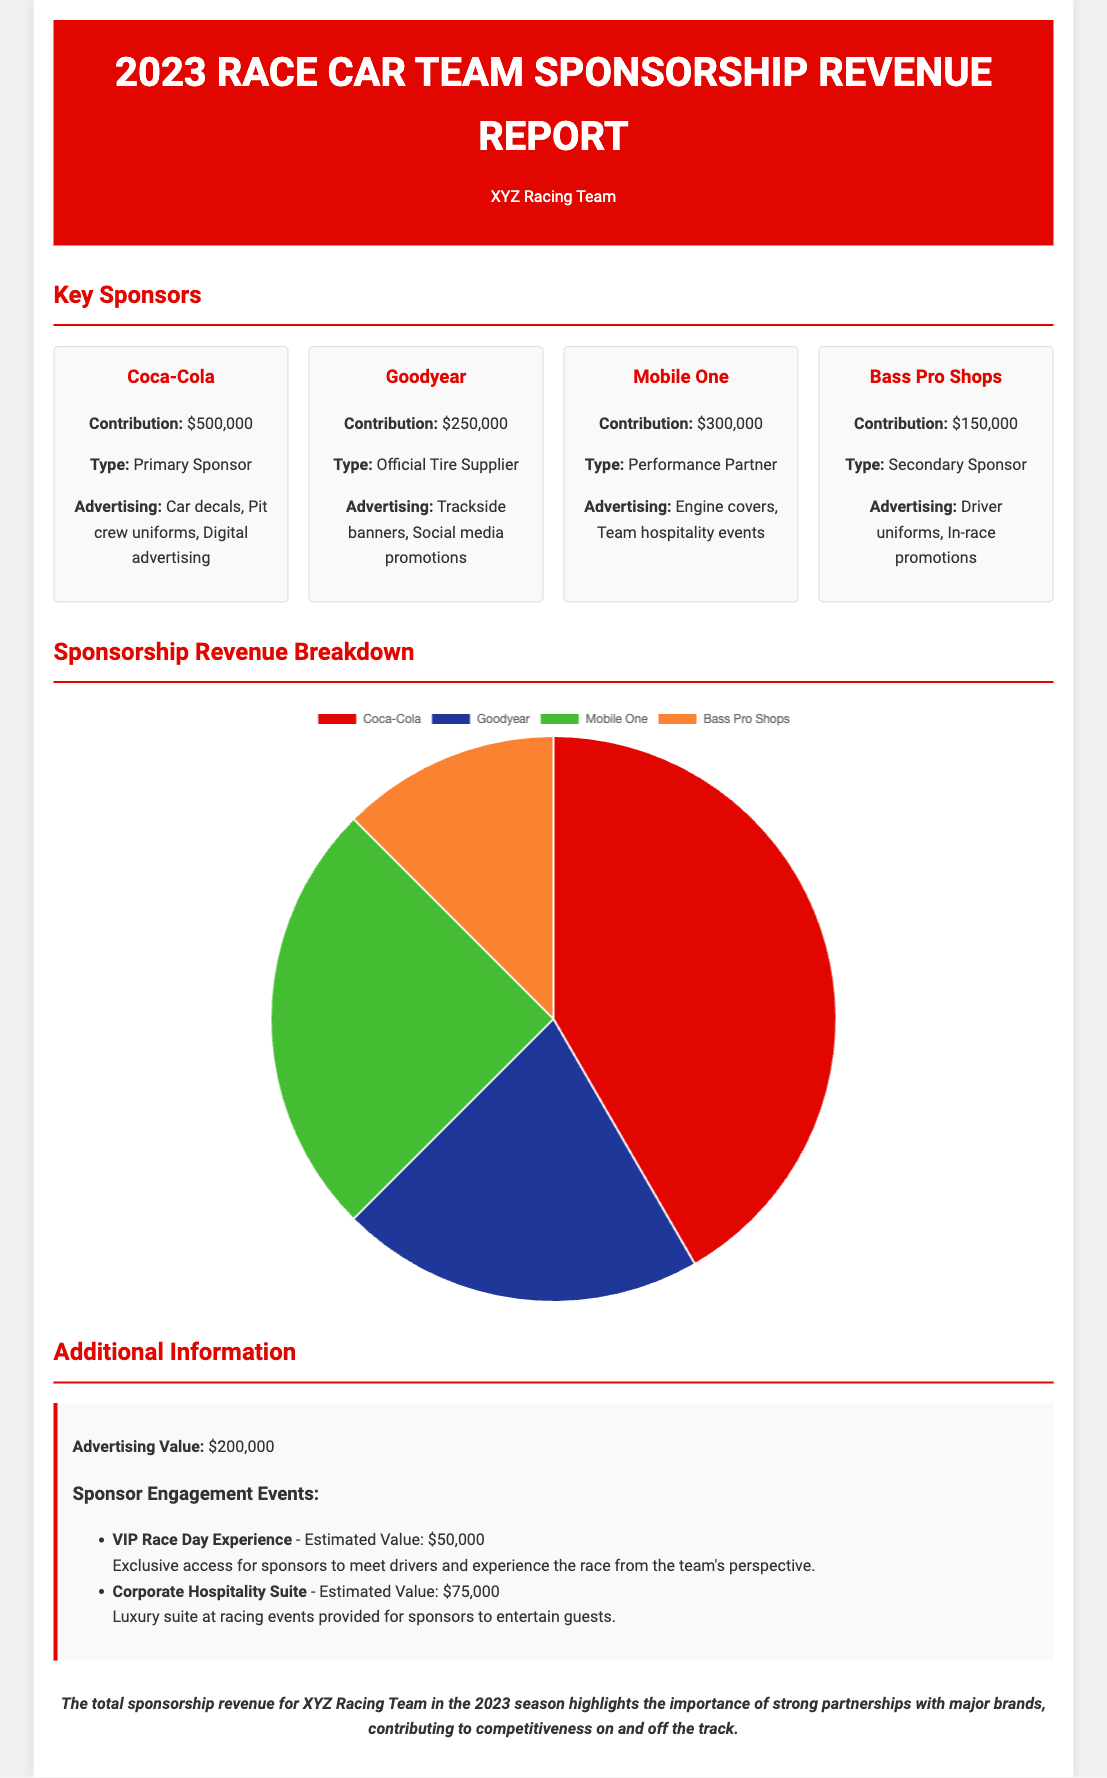What is the total contribution from Coca-Cola? The total contribution from Coca-Cola is stated in the document as $500,000.
Answer: $500,000 What type of sponsor is Goodyear? The document specifies Goodyear as the "Official Tire Supplier."
Answer: Official Tire Supplier How much did Mobile One contribute? Mobile One's contribution is detailed in the document as $300,000.
Answer: $300,000 How much is the advertising value reported? The document mentions an advertising value of $200,000.
Answer: $200,000 What is the estimated value of the Corporate Hospitality Suite? The estimated value for the Corporate Hospitality Suite is listed as $75,000.
Answer: $75,000 Which sponsor contributed the least amount? The least contribution mentioned in the report is from Bass Pro Shops, which is $150,000.
Answer: Bass Pro Shops What is the total amount contributed by all major sponsors? The total amount can be calculated by adding all contributions mentioned in the document, resulting in $1,400,000.
Answer: $1,400,000 What is the primary advertising method for Coca-Cola? The document cites several advertising methods, with car decals being a primary method for Coca-Cola.
Answer: Car decals What does the sponsorship revenue distribution chart represent? The chart visually represents the distribution of contributions from key sponsors in a pie chart format.
Answer: Contributions distribution 